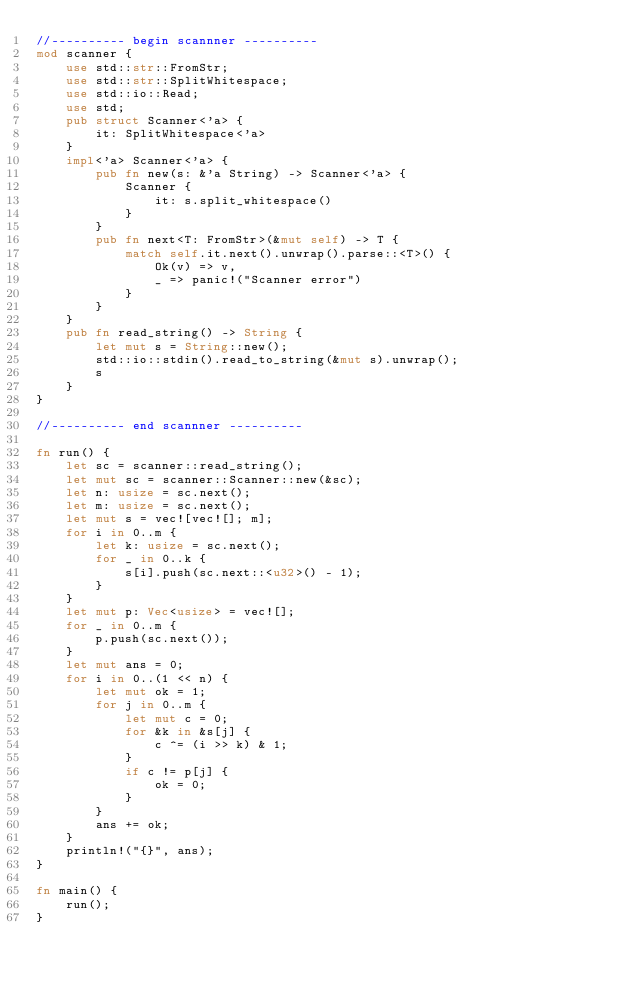<code> <loc_0><loc_0><loc_500><loc_500><_Rust_>//---------- begin scannner ----------
mod scanner {
    use std::str::FromStr;
    use std::str::SplitWhitespace;
    use std::io::Read;
    use std;
    pub struct Scanner<'a> {
        it: SplitWhitespace<'a>
    }
    impl<'a> Scanner<'a> {
        pub fn new(s: &'a String) -> Scanner<'a> {
            Scanner {
                it: s.split_whitespace()
            }
        }
        pub fn next<T: FromStr>(&mut self) -> T {
            match self.it.next().unwrap().parse::<T>() {
                Ok(v) => v,
                _ => panic!("Scanner error")
            }
        }
    }
    pub fn read_string() -> String {
        let mut s = String::new();
        std::io::stdin().read_to_string(&mut s).unwrap();
        s
    }
}

//---------- end scannner ----------

fn run() {
    let sc = scanner::read_string();
    let mut sc = scanner::Scanner::new(&sc);
    let n: usize = sc.next();
    let m: usize = sc.next();
    let mut s = vec![vec![]; m];
    for i in 0..m {
        let k: usize = sc.next();
        for _ in 0..k {
            s[i].push(sc.next::<u32>() - 1);
        }
    }
    let mut p: Vec<usize> = vec![];
    for _ in 0..m {
        p.push(sc.next());
    }
    let mut ans = 0;
    for i in 0..(1 << n) {
        let mut ok = 1;
        for j in 0..m {
            let mut c = 0;
            for &k in &s[j] {
                c ^= (i >> k) & 1;
            }
            if c != p[j] {
                ok = 0;
            }
        }
        ans += ok;
    }
    println!("{}", ans);
}

fn main() {
    run();
}
</code> 